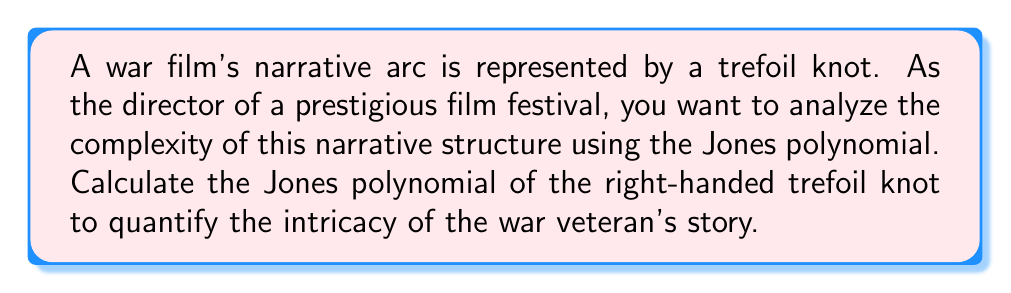Provide a solution to this math problem. To calculate the Jones polynomial of the right-handed trefoil knot, we'll follow these steps:

1. Start with the skein relation for the Jones polynomial:
   $$t^{-1}V(L_+) - tV(L_-) = (t^{1/2} - t^{-1/2})V(L_0)$$
   Where $L_+$, $L_-$, and $L_0$ represent positive crossing, negative crossing, and smoothed crossing, respectively.

2. For the right-handed trefoil knot, we have three positive crossings. Let's denote the trefoil as $T$.

3. Apply the skein relation to one crossing:
   $$t^{-1}V(T) - tV(H) = (t^{1/2} - t^{-1/2})V(U)$$
   Where $H$ is the Hopf link and $U$ is the unknot.

4. We know that $V(U) = 1$ for the unknot.

5. For the Hopf link, we can calculate:
   $$V(H) = -t^{1/2} - t^{-3/2}$$

6. Substitute these values into the skein relation:
   $$t^{-1}V(T) - t(-t^{1/2} - t^{-3/2}) = (t^{1/2} - t^{-1/2})$$

7. Solve for $V(T)$:
   $$V(T) = t(t^{1/2} - t^{-1/2}) + t^2(-t^{1/2} - t^{-3/2})$$

8. Simplify:
   $$V(T) = t^{3/2} - t^{1/2} - t^{5/2} - t^{1/2}$$
   $$V(T) = t^{-1} + t^{-3} - t^{-4}$$

This polynomial quantifies the complexity of the war film's narrative arc, represented by the trefoil knot.
Answer: $t^{-1} + t^{-3} - t^{-4}$ 